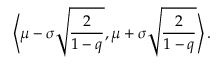<formula> <loc_0><loc_0><loc_500><loc_500>\left \langle \mu - \sigma \sqrt { \frac { 2 } { 1 - q } } , \mu + \sigma \sqrt { \frac { 2 } { 1 - q } } \right \rangle .</formula> 